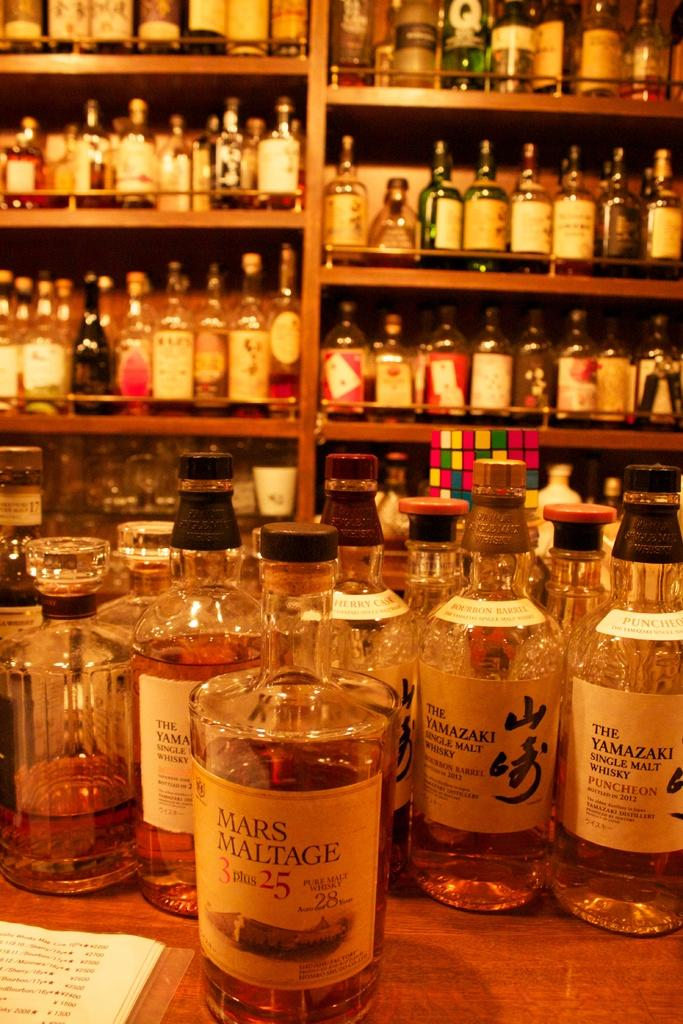<image>
Provide a brief description of the given image. Lots of bottles of alcohol including mars maltage 